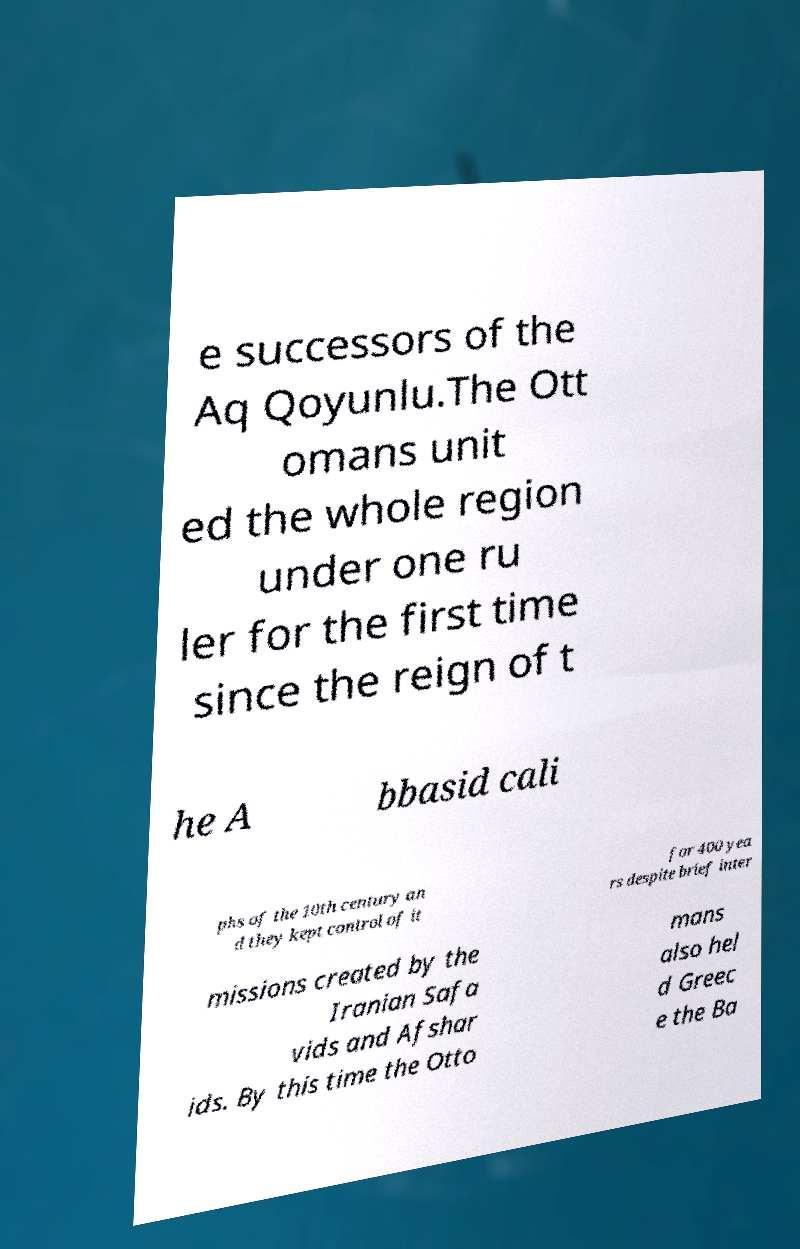Please identify and transcribe the text found in this image. e successors of the Aq Qoyunlu.The Ott omans unit ed the whole region under one ru ler for the first time since the reign of t he A bbasid cali phs of the 10th century an d they kept control of it for 400 yea rs despite brief inter missions created by the Iranian Safa vids and Afshar ids. By this time the Otto mans also hel d Greec e the Ba 